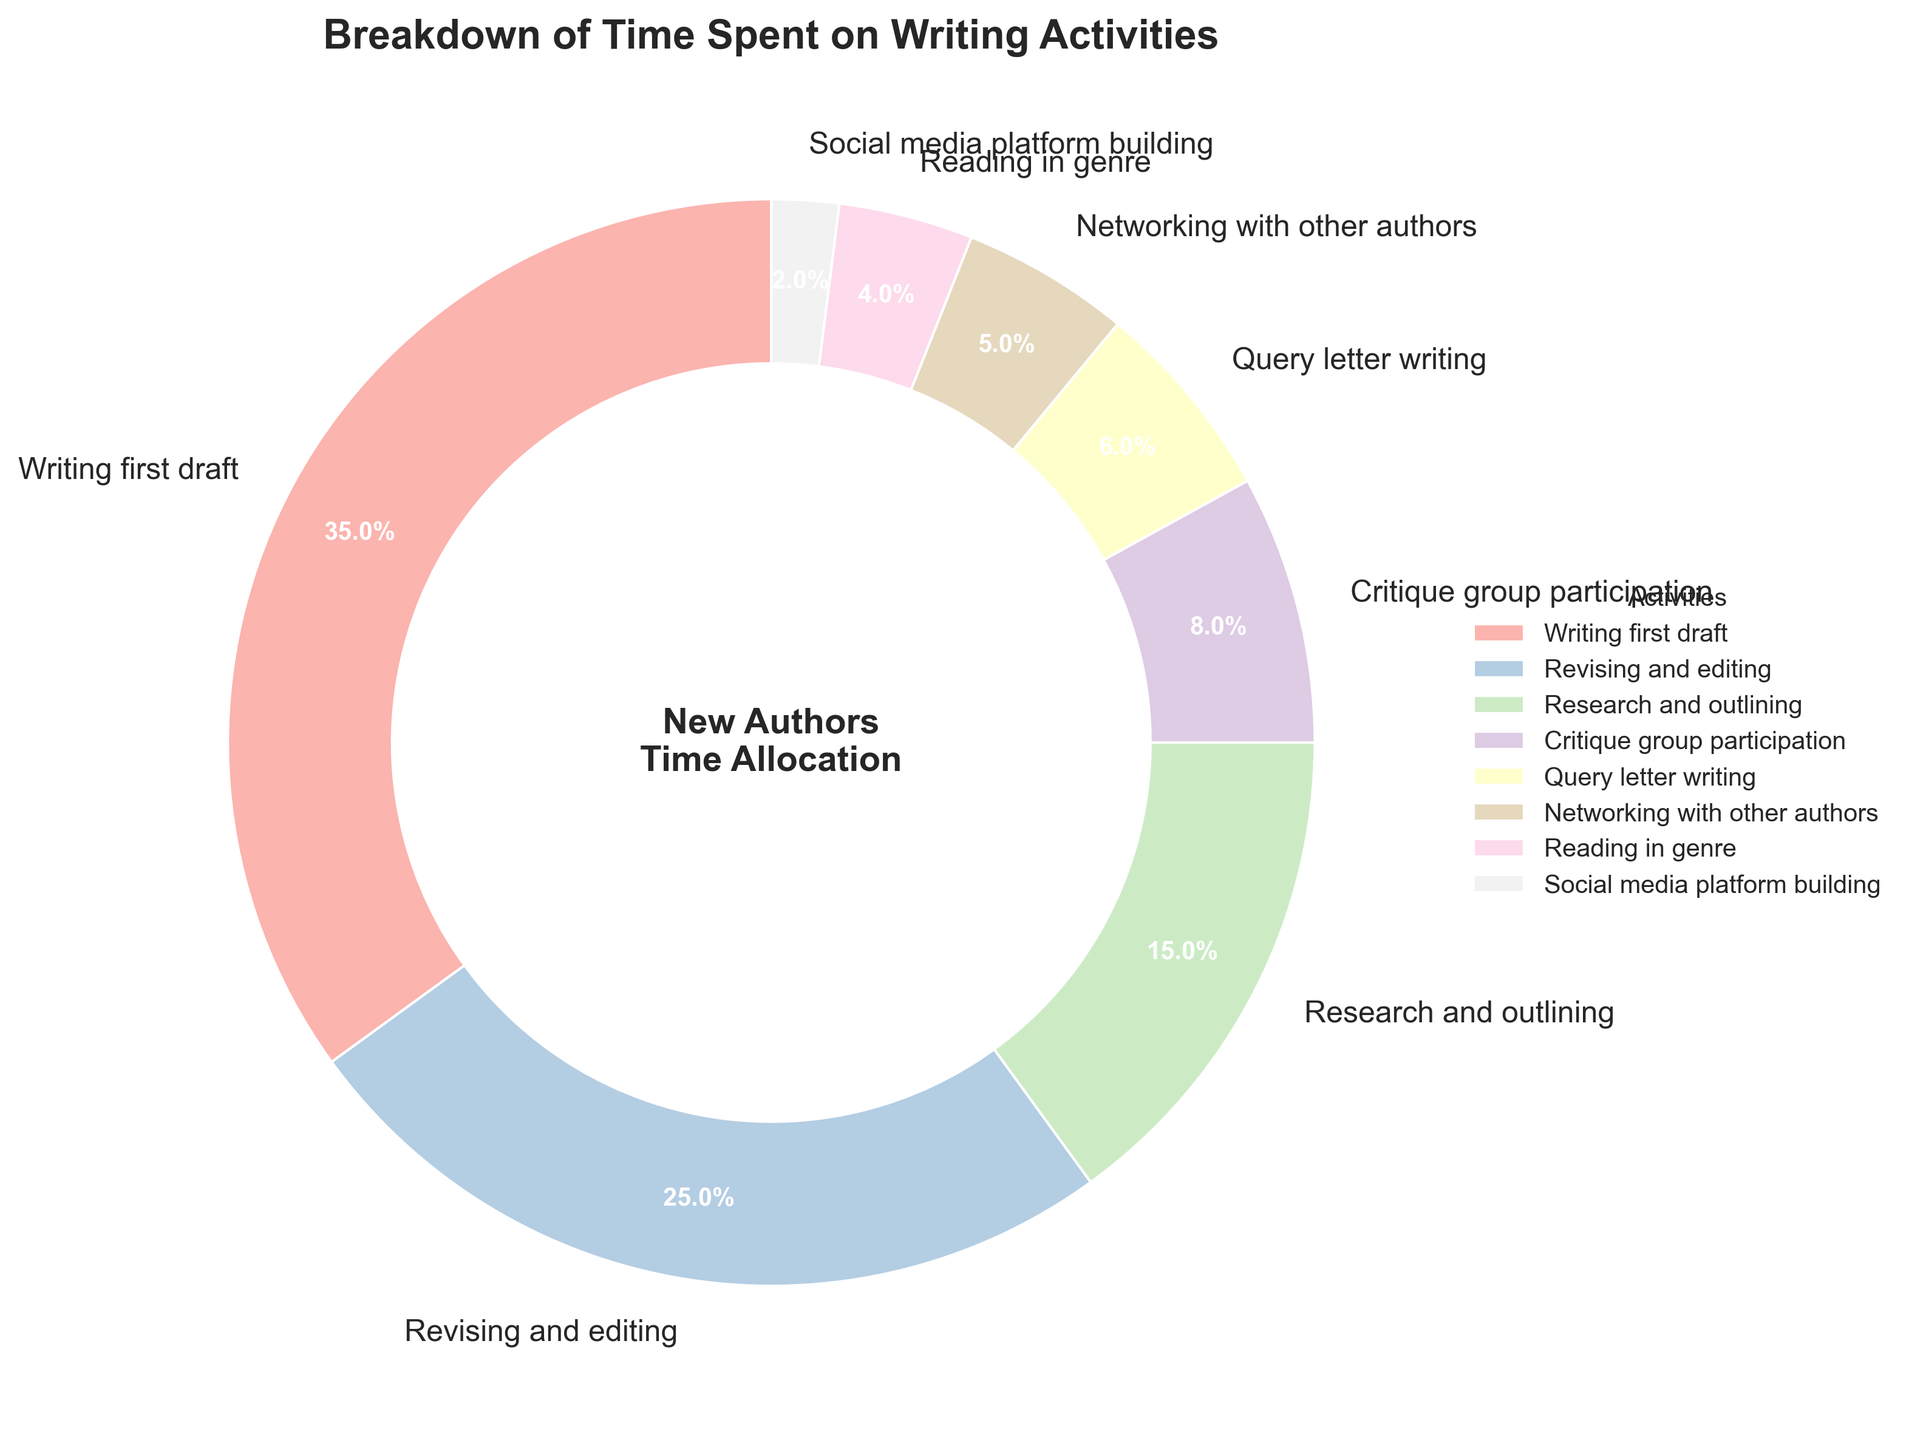What's the percentage of time spent on research and outlining and critique group participation combined? The percentage of time spent on research and outlining is 15%, and for critique group participation, it is 8%. Adding these together gives 15% + 8% = 23%.
Answer: 23% Which activity takes the most time according to the chart? The activity with the highest percentage is writing the first draft, which accounts for 35% of the time spent on writing activities.
Answer: Writing first draft Is more time spent on revising and editing or on research and outlining? Revising and editing accounts for 25% of the time, while research and outlining account for 15%. 25% is greater than 15%, so more time is spent on revising and editing.
Answer: Revising and editing What is the combined percentage of time spent on query letter writing, networking with other authors, reading in genre, and social media platform building? Adding the percentages for query letter writing (6%), networking with other authors (5%), reading in the genre (4%), and social media platform building (2%) gives 6% + 5% + 4% + 2% = 17%.
Answer: 17% How does the percentage of time spent on critique group participation compare to that on reading in genre? The time spent on critique group participation is 8%, while the time spent on reading in genre is 4%. 8% is double that of 4%.
Answer: Double Which activities together make up exactly half of the pie chart? Writing the first draft takes up 35%, and revising and editing take 25%. Adding these gives 35% + 25% = 60%, which is not half. Research and outlining (15%) and critique group participation (8%) together also do not add up to exactly 50%. However, query letter writing (6%), networking (5%), reading in genre (4%), and social media platform building (2%) together add up to 17%. None of the combined pairs provided 50%.
Answer: None What is the percentage difference between the time spent on writing the first draft and the time spent on social media platform building? Writing the first draft accounts for 35%, and social media platform building accounts for 2%. The difference is 35% - 2% = 33%.
Answer: 33% Between revising and editing and writing the first draft, which activity takes less time and by how much? Revising and editing takes 25%, while writing the first draft takes 35%. The difference is 35% - 25% = 10%, so revising and editing takes 10% less time than writing the first draft.
Answer: Revising and editing, 10% If the time spent on research and outlining were increased by 10%, what would the new percentage be? The current percentage for research and outlining is 15%. Increasing this by 10% of 15% (0.10 * 15 = 1.5%) results in 15% + 1.5% = 16.5%.
Answer: 16.5% What fraction of the pie chart is dedicated to networking with other authors and reading in genre combined? Networking with other authors takes 5% and reading in genre takes 4%. Together, they sum to 5% + 4% = 9%. In terms of a fraction, 9% can be expressed as 9/100, which simplifies to 9/100 as the minimal fraction.
Answer: 9/100 